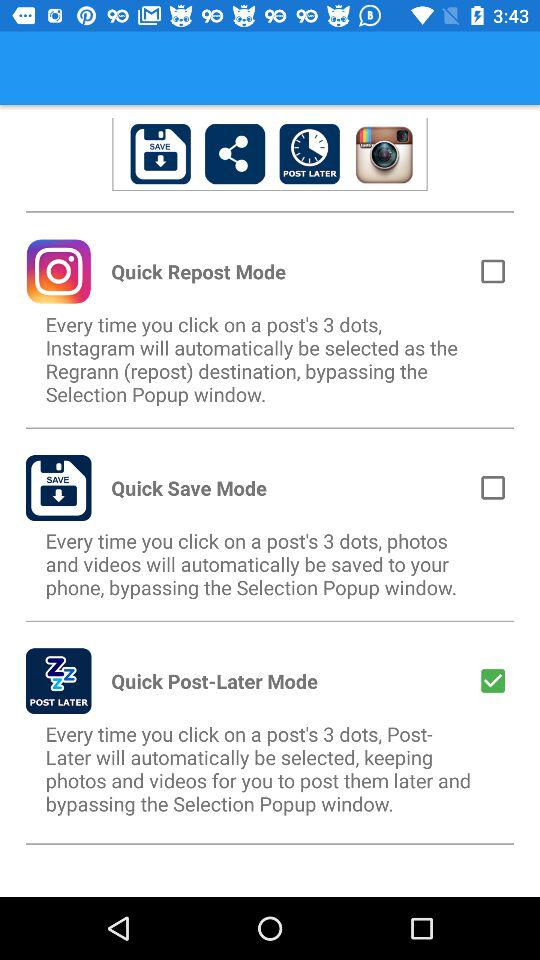Which mode is checked? The checked mode is "Quick Post-Later Mode". 